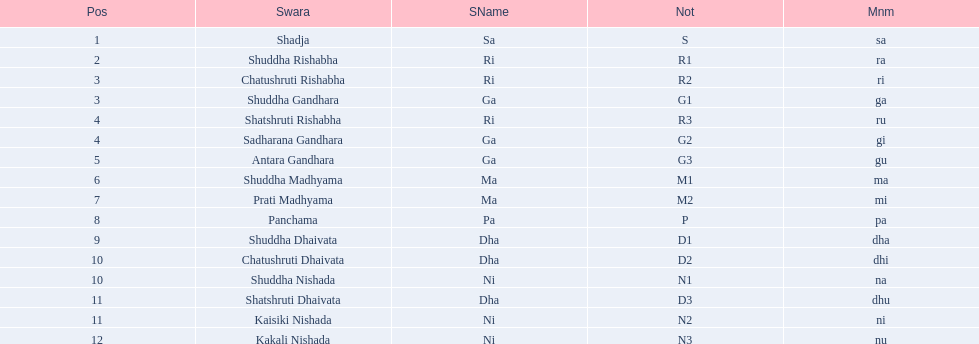What is the name of the swara that comes after panchama? Shuddha Dhaivata. 